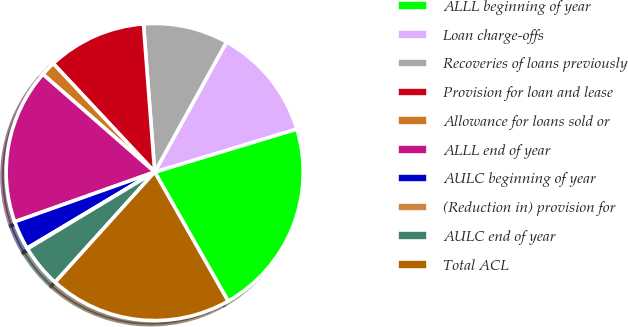<chart> <loc_0><loc_0><loc_500><loc_500><pie_chart><fcel>ALLL beginning of year<fcel>Loan charge-offs<fcel>Recoveries of loans previously<fcel>Provision for loan and lease<fcel>Allowance for loans sold or<fcel>ALLL end of year<fcel>AULC beginning of year<fcel>(Reduction in) provision for<fcel>AULC end of year<fcel>Total ACL<nl><fcel>21.45%<fcel>12.29%<fcel>9.24%<fcel>10.76%<fcel>1.6%<fcel>16.87%<fcel>3.13%<fcel>0.08%<fcel>4.66%<fcel>19.92%<nl></chart> 